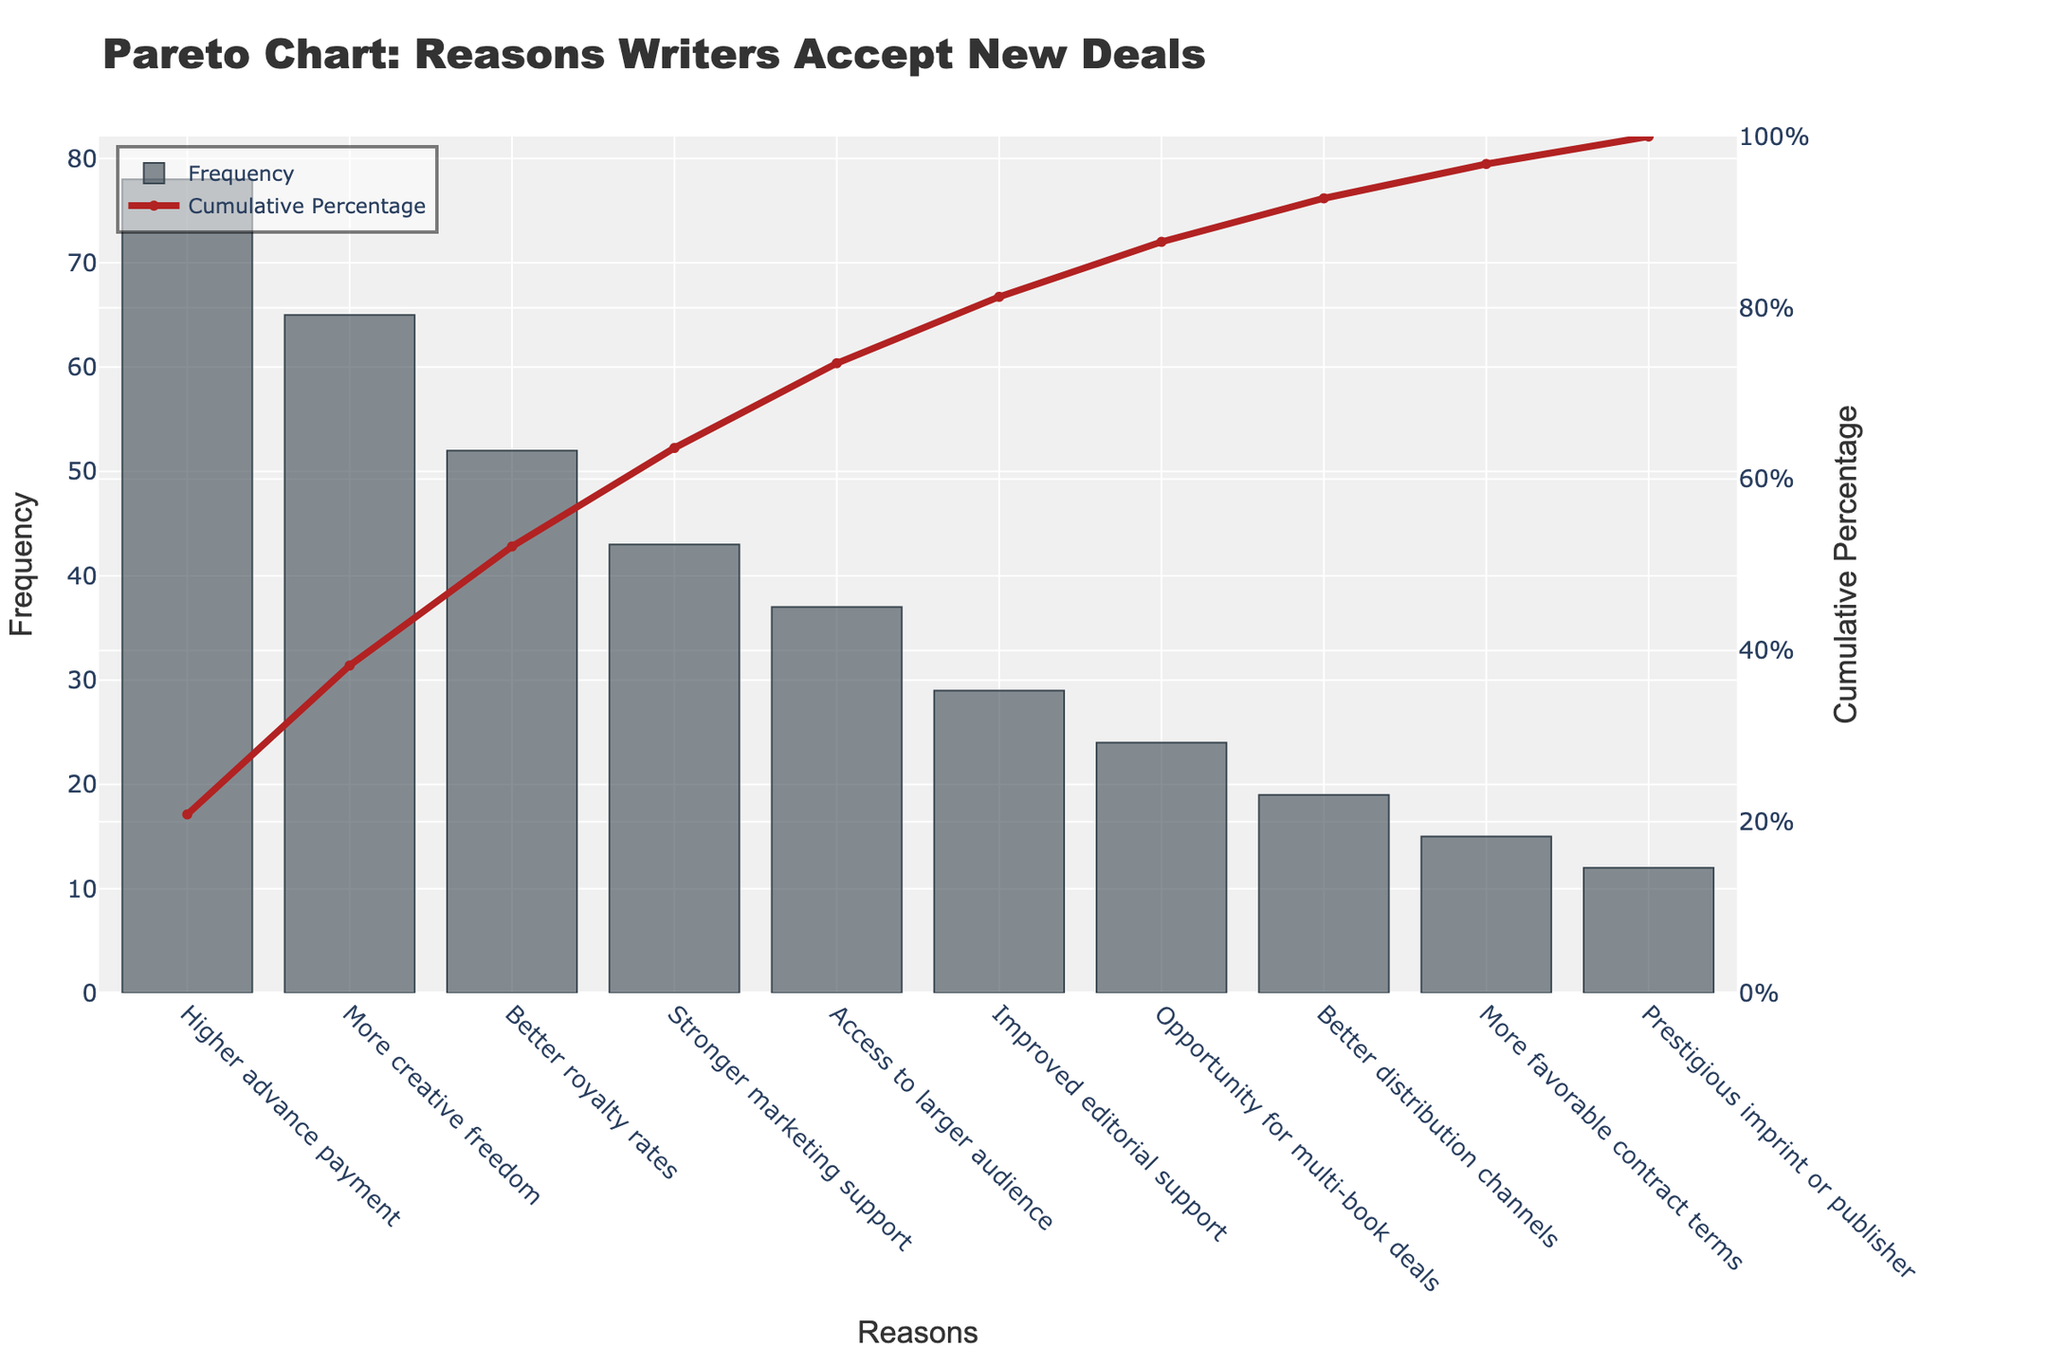What is the most common reason writers cite for accepting new deals? The bar chart shows the frequencies of different reasons why writers accept new deals. The highest bar represents the most common reason.
Answer: Higher advance payment How many writers cited 'More creative freedom' as their reason for accepting new deals? The bar chart shows the frequency on the y-axis. The bar for 'More creative freedom' reaches up to 65.
Answer: 65 What is the cumulative percentage for the top three reasons? To find the cumulative percentage, add the frequencies of the top three reasons: 78 (Higher advance payment), 65 (More creative freedom), and 52 (Better royalty rates). Sum these to get 195. Calculate the cumulative percentage: (195 / total frequency) * 100. The total frequency is 374, so (195/374)*100 = 52.14%.
Answer: 52.14% Which reason has a higher frequency: 'Better distribution channels' or 'Improved editorial support'? Compare the heights of the bars for 'Better distribution channels' (19) and 'Improved editorial support' (29).
Answer: Improved editorial support By what percentage does the 'Stronger marketing support' contribute to the total frequency? The frequency for 'Stronger marketing support' is 43. To find the percentage, divide 43 by the total frequency (374) and multiply by 100: (43/374)*100 ≈ 11.5%.
Answer: 11.5% At which reason does the cumulative percentage curve cross 50%? Find where the cumulative percentage line crosses the 50% mark. This occurs between 'More creative freedom' (44.92%) and 'Better royalty rates' (58.56%).
Answer: Better royalty rates If you combine the frequencies of 'Access to larger audience' and 'More favorable contract terms,' how many writers does it sum to? Add the frequencies of 'Access to larger audience' (37) and 'More favorable contract terms' (15): 37+15=52.
Answer: 52 Which reasons contribute to at least 80% of the cumulative percentage? First, identify the cumulative percentage thresholds that reach at least 80%: 'Higher advance payment,' 'More creative freedom,' 'Better royalty rates,' and 'Stronger marketing support' sum to a cumulative percentage of 63.37+58.56+75.67+87.80 respectively.
Answer: Up to 'Stronger marketing support' What is the least cited reason for accepting new deals? The shortest bar in the bar chart corresponds to the least cited reason.
Answer: Prestigious imprint or publisher How do the frequencies of 'More creative freedom' and 'Better royalty rates' compare? Compare the heights of the bars; 'More creative freedom' (65) and 'Better royalty rates' (52).
Answer: More creative freedom is higher 